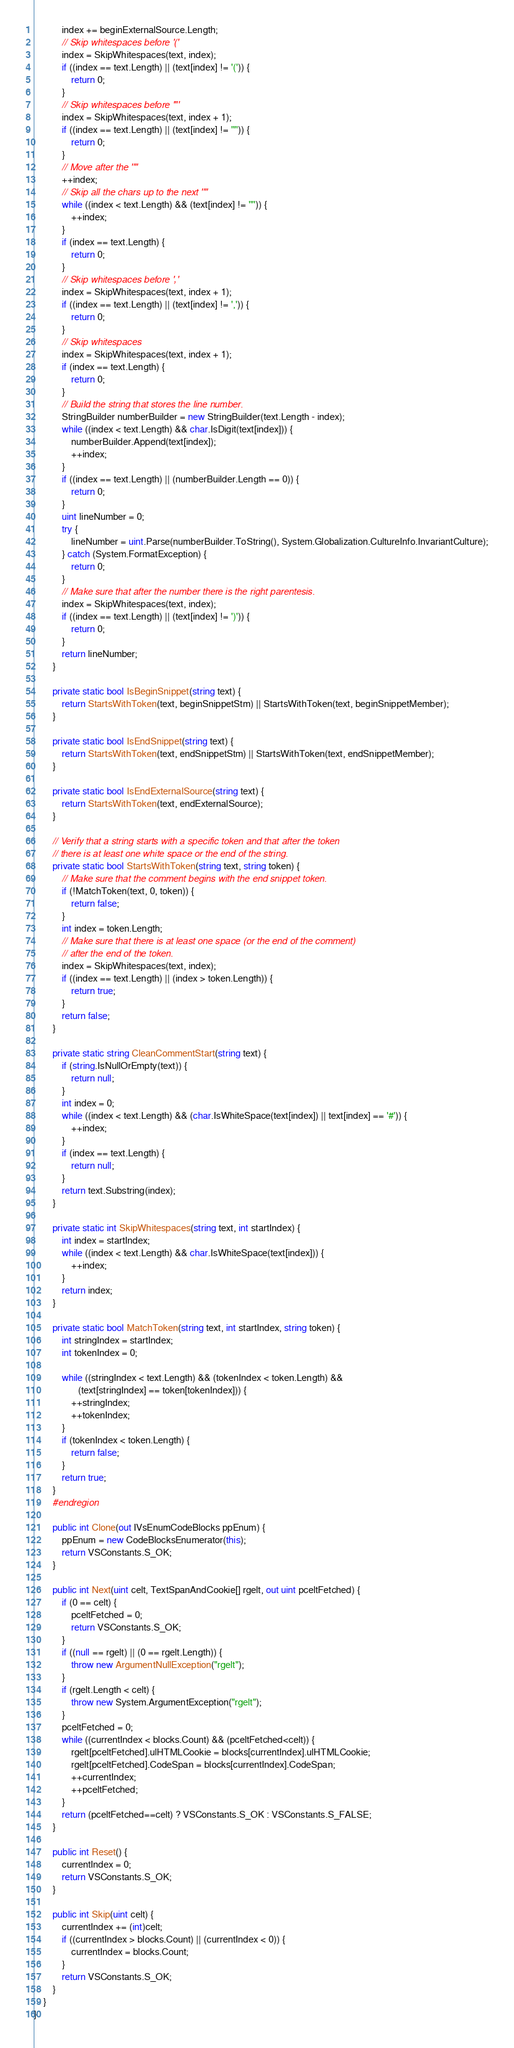Convert code to text. <code><loc_0><loc_0><loc_500><loc_500><_C#_>            index += beginExternalSource.Length;
            // Skip whitespaces before '('
            index = SkipWhitespaces(text, index);
            if ((index == text.Length) || (text[index] != '(')) {
                return 0;
            }
            // Skip whitespaces before '"'
            index = SkipWhitespaces(text, index + 1);
            if ((index == text.Length) || (text[index] != '"')) {
                return 0;
            }
            // Move after the '"'
            ++index;
            // Skip all the chars up to the next '"'
            while ((index < text.Length) && (text[index] != '"')) {
                ++index;
            }
            if (index == text.Length) {
                return 0;
            }
            // Skip whitespaces before ','
            index = SkipWhitespaces(text, index + 1);
            if ((index == text.Length) || (text[index] != ',')) {
                return 0;
            }
            // Skip whitespaces
            index = SkipWhitespaces(text, index + 1);
            if (index == text.Length) {
                return 0;
            }
            // Build the string that stores the line number.
            StringBuilder numberBuilder = new StringBuilder(text.Length - index);
            while ((index < text.Length) && char.IsDigit(text[index])) {
                numberBuilder.Append(text[index]);
                ++index;
            }
            if ((index == text.Length) || (numberBuilder.Length == 0)) {
                return 0;
            }
            uint lineNumber = 0;
            try {
                lineNumber = uint.Parse(numberBuilder.ToString(), System.Globalization.CultureInfo.InvariantCulture);
            } catch (System.FormatException) {
                return 0;
            }
            // Make sure that after the number there is the right parentesis.
            index = SkipWhitespaces(text, index);
            if ((index == text.Length) || (text[index] != ')')) {
                return 0;
            }
            return lineNumber;
        }

        private static bool IsBeginSnippet(string text) {
            return StartsWithToken(text, beginSnippetStm) || StartsWithToken(text, beginSnippetMember);
        }

        private static bool IsEndSnippet(string text) {
            return StartsWithToken(text, endSnippetStm) || StartsWithToken(text, endSnippetMember);
        }

        private static bool IsEndExternalSource(string text) {
            return StartsWithToken(text, endExternalSource);
        }

        // Verify that a string starts with a specific token and that after the token
        // there is at least one white space or the end of the string.
        private static bool StartsWithToken(string text, string token) {
            // Make sure that the comment begins with the end snippet token.
            if (!MatchToken(text, 0, token)) {
                return false;
            }
            int index = token.Length;
            // Make sure that there is at least one space (or the end of the comment)
            // after the end of the token.
            index = SkipWhitespaces(text, index);
            if ((index == text.Length) || (index > token.Length)) {
                return true;
            }
            return false;
        }

        private static string CleanCommentStart(string text) {
            if (string.IsNullOrEmpty(text)) {
                return null;
            }
            int index = 0;
            while ((index < text.Length) && (char.IsWhiteSpace(text[index]) || text[index] == '#')) {
                ++index;
            }
            if (index == text.Length) {
                return null;
            }
            return text.Substring(index);
        }

        private static int SkipWhitespaces(string text, int startIndex) {
            int index = startIndex;
            while ((index < text.Length) && char.IsWhiteSpace(text[index])) {
                ++index;
            }
            return index;
        }

        private static bool MatchToken(string text, int startIndex, string token) {
            int stringIndex = startIndex;
            int tokenIndex = 0;

            while ((stringIndex < text.Length) && (tokenIndex < token.Length) &&
                   (text[stringIndex] == token[tokenIndex])) {
                ++stringIndex;
                ++tokenIndex;
            }
            if (tokenIndex < token.Length) {
                return false;
            }
            return true;
        }
        #endregion

        public int Clone(out IVsEnumCodeBlocks ppEnum) {
            ppEnum = new CodeBlocksEnumerator(this);
            return VSConstants.S_OK;
        }

        public int Next(uint celt, TextSpanAndCookie[] rgelt, out uint pceltFetched) {
            if (0 == celt) {
                pceltFetched = 0;
                return VSConstants.S_OK;
            }
            if ((null == rgelt) || (0 == rgelt.Length)) {
                throw new ArgumentNullException("rgelt");
            }
            if (rgelt.Length < celt) {
                throw new System.ArgumentException("rgelt");
            }
            pceltFetched = 0;
            while ((currentIndex < blocks.Count) && (pceltFetched<celt)) {
                rgelt[pceltFetched].ulHTMLCookie = blocks[currentIndex].ulHTMLCookie;
                rgelt[pceltFetched].CodeSpan = blocks[currentIndex].CodeSpan;
                ++currentIndex;
                ++pceltFetched;
            }
            return (pceltFetched==celt) ? VSConstants.S_OK : VSConstants.S_FALSE;
        }

        public int Reset() {
            currentIndex = 0;
            return VSConstants.S_OK;
        }

        public int Skip(uint celt) {
            currentIndex += (int)celt;
            if ((currentIndex > blocks.Count) || (currentIndex < 0)) {
                currentIndex = blocks.Count;
            }
            return VSConstants.S_OK;
        }
    }
}
</code> 